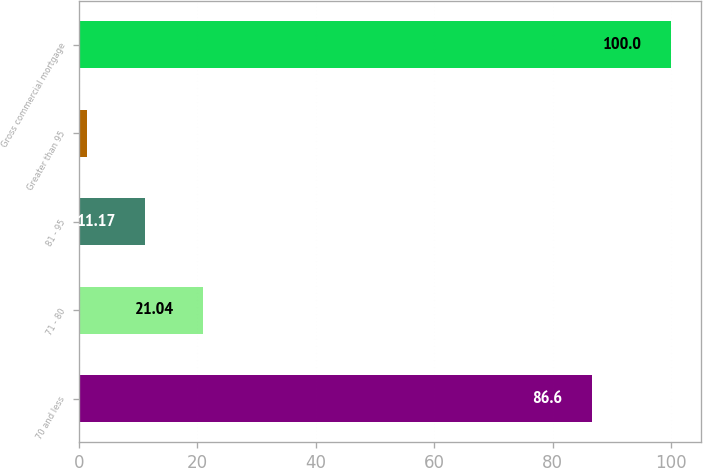<chart> <loc_0><loc_0><loc_500><loc_500><bar_chart><fcel>70 and less<fcel>71 - 80<fcel>81 - 95<fcel>Greater than 95<fcel>Gross commercial mortgage<nl><fcel>86.6<fcel>21.04<fcel>11.17<fcel>1.3<fcel>100<nl></chart> 